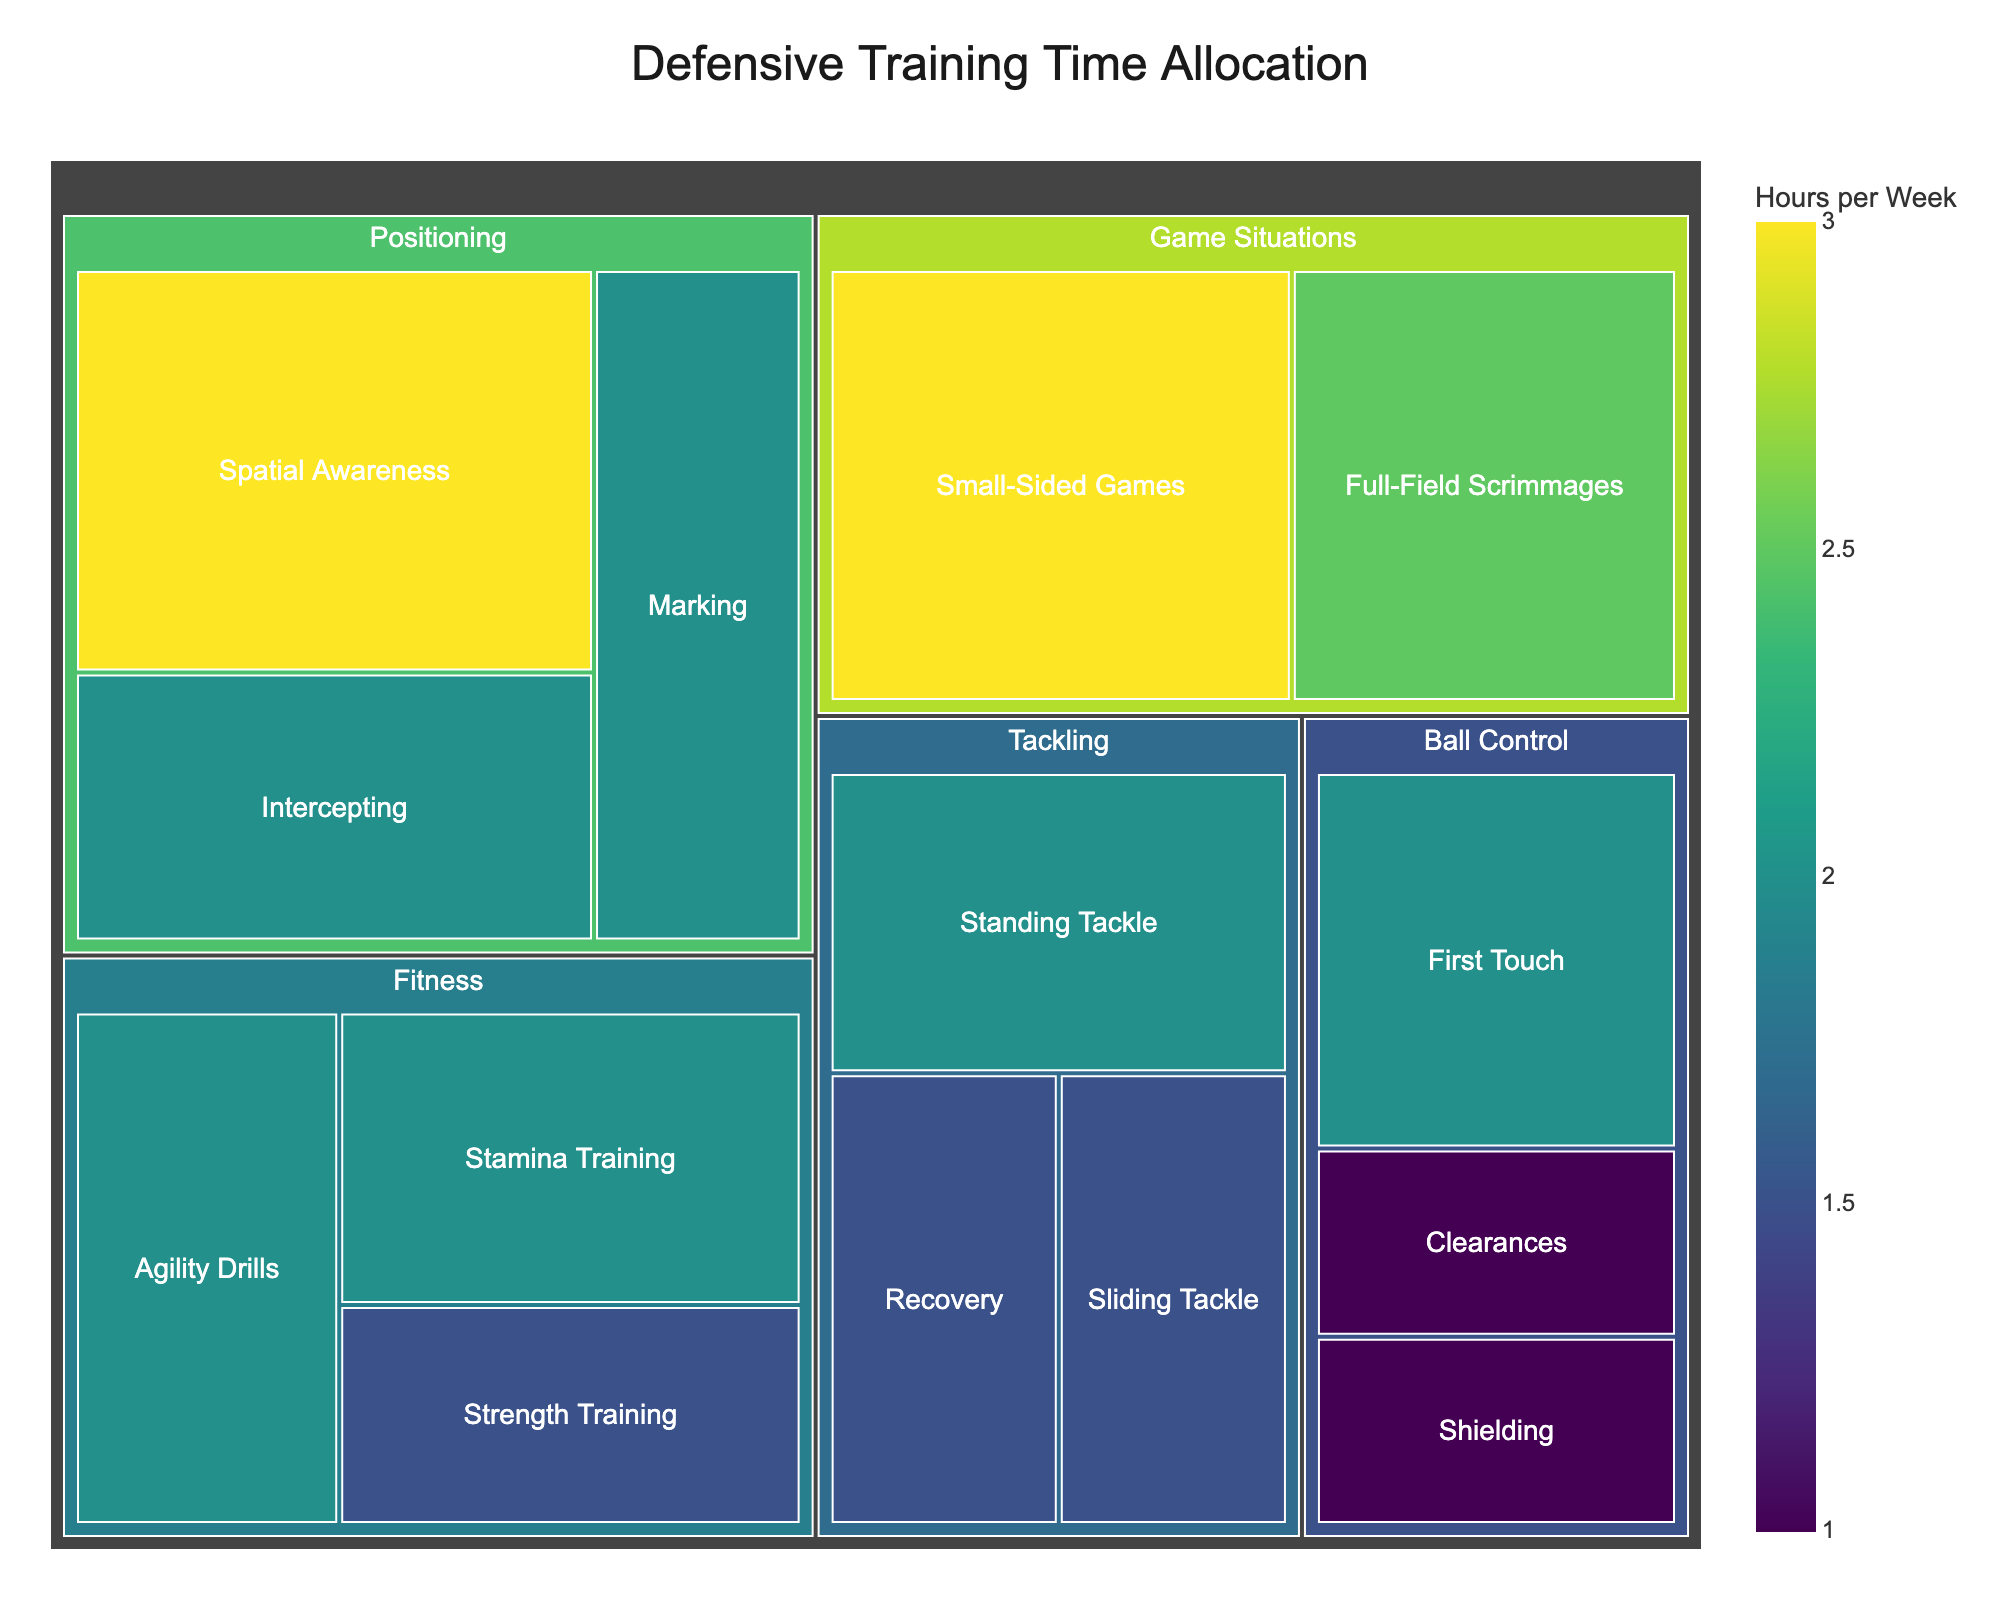what's the total time allocated to "Positioning" training? Sum the hours for all subcategories under "Positioning": Spatial Awareness (3), Marking (2), and Intercepting (2). The total is 3 + 2 + 2 = 7 hours per week.
Answer: 7 Which subcategory has the most training time allocated? Look for the subcategory with the largest value. "Spatial Awareness" in "Positioning" has the highest time allocated at 3 hours per week.
Answer: Spatial Awareness How does the training time for "Agility Drills" compare to "Standing Tackle"? Compare the values for "Agility Drills" (2 hours) and "Standing Tackle" (2 hours). Both have the same amount of training time.
Answer: Same What's the difference in training time between "Small-Sided Games" and "Full-Field Scrimmages"? The time allocated to "Small-Sided Games" is 3 hours, and for "Full-Field Scrimmages" it's 2.5 hours. The difference is 3 - 2.5 = 0.5 hours.
Answer: 0.5 What's the average training time across all subcategories of "Tackling"? Sum the hours for all "Tackling" subcategories: Standing Tackle (2), Sliding Tackle (1.5), and Recovery (1.5). The total is 2 + 1.5 + 1.5 = 5. Divide by the number of subcategories (3): 5 / 3 ≈ 1.67 hours.
Answer: 1.67 Which category has the least total training time? Sum the training times for each category and find the smallest total. "Ball Control" has a total of 2 + 1 + 1 = 4 hours, which is the least compared to other categories.
Answer: Ball Control How much more time is spent on "Positioning" than "Fitness"? "Positioning" has 7 hours, "Fitness" has 2 + 2 + 1.5 = 5.5 hours. The difference is 7 - 5.5 = 1.5 hours.
Answer: 1.5 What's the proportion of time spent on "Intercepting" relative to the total time spent on "Positioning"? "Intercepting" has 2 hours. Total "Positioning" time is 7 hours. The proportion is 2 / 7 ≈ 0.29 or 29%.
Answer: 29% 